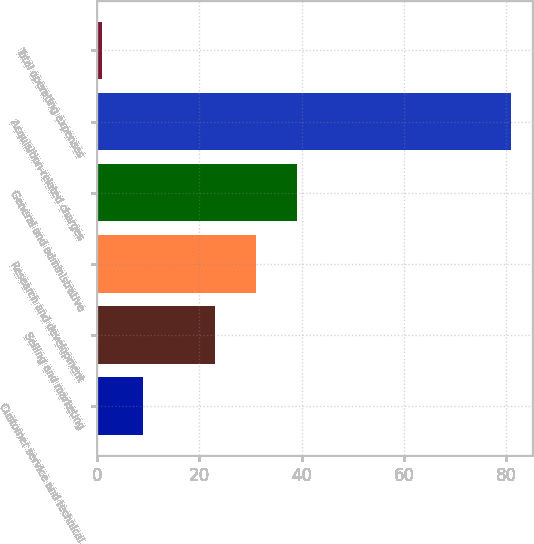Convert chart. <chart><loc_0><loc_0><loc_500><loc_500><bar_chart><fcel>Customer service and technical<fcel>Selling and marketing<fcel>Research and development<fcel>General and administrative<fcel>Acquisition-related charges<fcel>Total operating expenses<nl><fcel>9<fcel>23<fcel>31<fcel>39<fcel>81<fcel>1<nl></chart> 